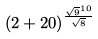Convert formula to latex. <formula><loc_0><loc_0><loc_500><loc_500>( 2 + 2 0 ) ^ { \frac { \sqrt { 9 } ^ { 1 0 } } { \sqrt { 8 } } }</formula> 